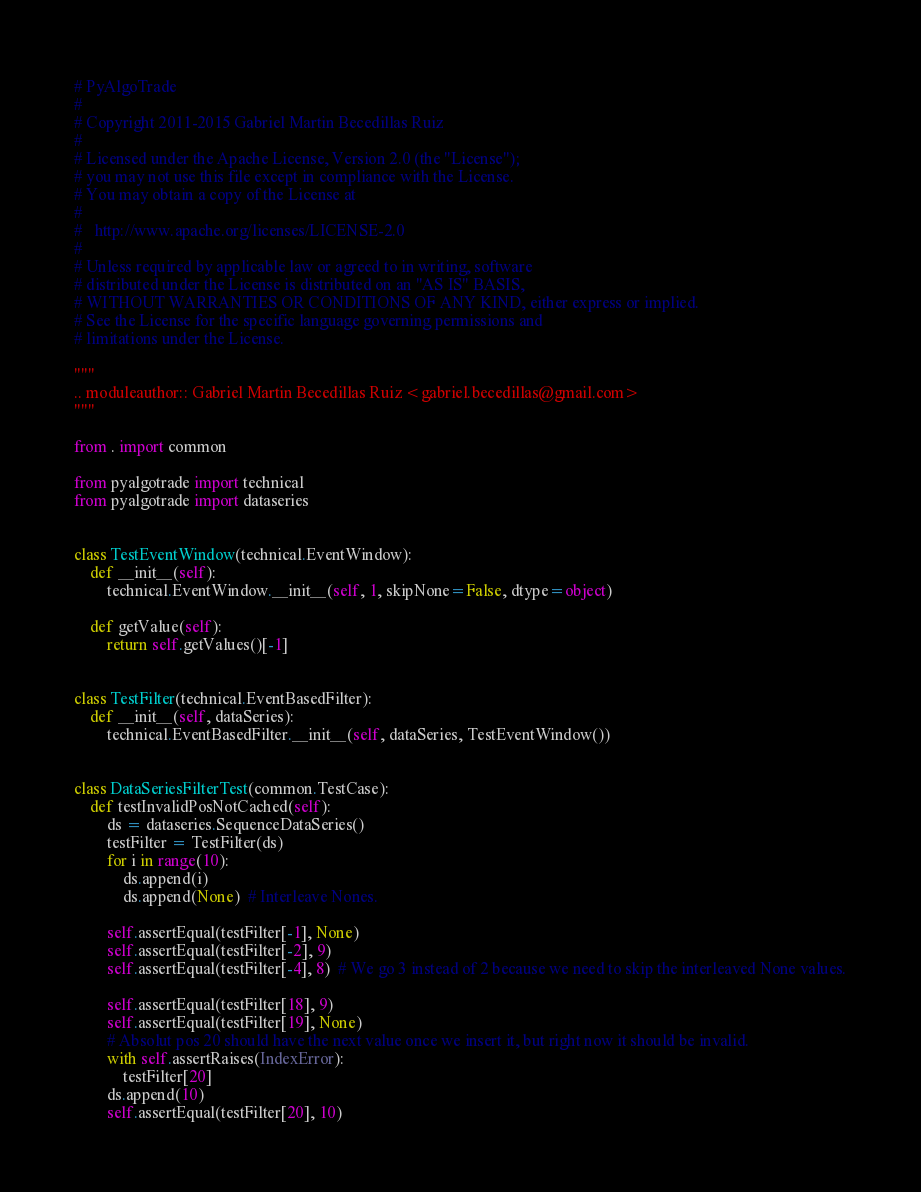Convert code to text. <code><loc_0><loc_0><loc_500><loc_500><_Python_># PyAlgoTrade
#
# Copyright 2011-2015 Gabriel Martin Becedillas Ruiz
#
# Licensed under the Apache License, Version 2.0 (the "License");
# you may not use this file except in compliance with the License.
# You may obtain a copy of the License at
#
#   http://www.apache.org/licenses/LICENSE-2.0
#
# Unless required by applicable law or agreed to in writing, software
# distributed under the License is distributed on an "AS IS" BASIS,
# WITHOUT WARRANTIES OR CONDITIONS OF ANY KIND, either express or implied.
# See the License for the specific language governing permissions and
# limitations under the License.

"""
.. moduleauthor:: Gabriel Martin Becedillas Ruiz <gabriel.becedillas@gmail.com>
"""

from . import common

from pyalgotrade import technical
from pyalgotrade import dataseries


class TestEventWindow(technical.EventWindow):
    def __init__(self):
        technical.EventWindow.__init__(self, 1, skipNone=False, dtype=object)

    def getValue(self):
        return self.getValues()[-1]


class TestFilter(technical.EventBasedFilter):
    def __init__(self, dataSeries):
        technical.EventBasedFilter.__init__(self, dataSeries, TestEventWindow())


class DataSeriesFilterTest(common.TestCase):
    def testInvalidPosNotCached(self):
        ds = dataseries.SequenceDataSeries()
        testFilter = TestFilter(ds)
        for i in range(10):
            ds.append(i)
            ds.append(None)  # Interleave Nones.

        self.assertEqual(testFilter[-1], None)
        self.assertEqual(testFilter[-2], 9)
        self.assertEqual(testFilter[-4], 8)  # We go 3 instead of 2 because we need to skip the interleaved None values.

        self.assertEqual(testFilter[18], 9)
        self.assertEqual(testFilter[19], None)
        # Absolut pos 20 should have the next value once we insert it, but right now it should be invalid.
        with self.assertRaises(IndexError):
            testFilter[20]
        ds.append(10)
        self.assertEqual(testFilter[20], 10)
</code> 